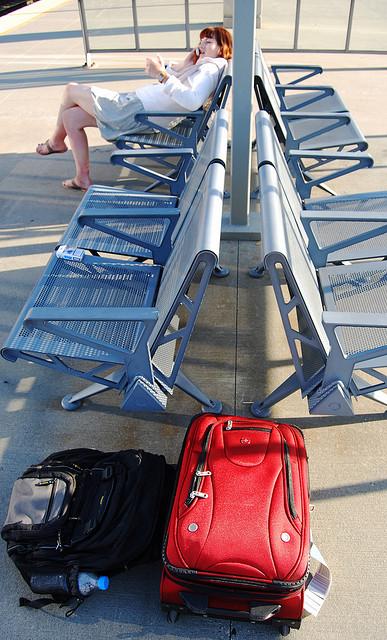How many backpacks?
Answer briefly. 1. What is in the backpack's side pocket?
Write a very short answer. Water bottle. What is the bench made out of?
Answer briefly. Metal. What color is the woman's hair?
Write a very short answer. Red. 